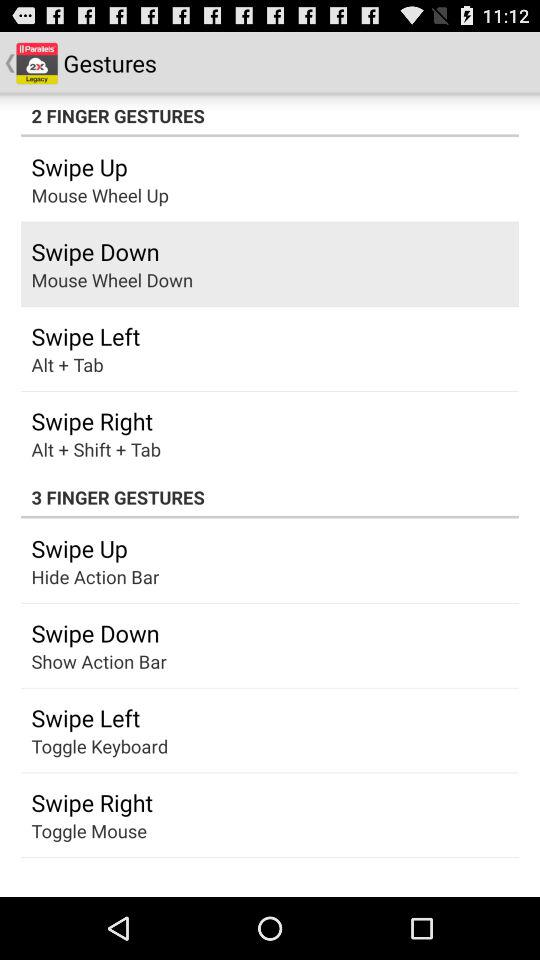How many of the gestures are used to show or hide the action bar?
Answer the question using a single word or phrase. 2 